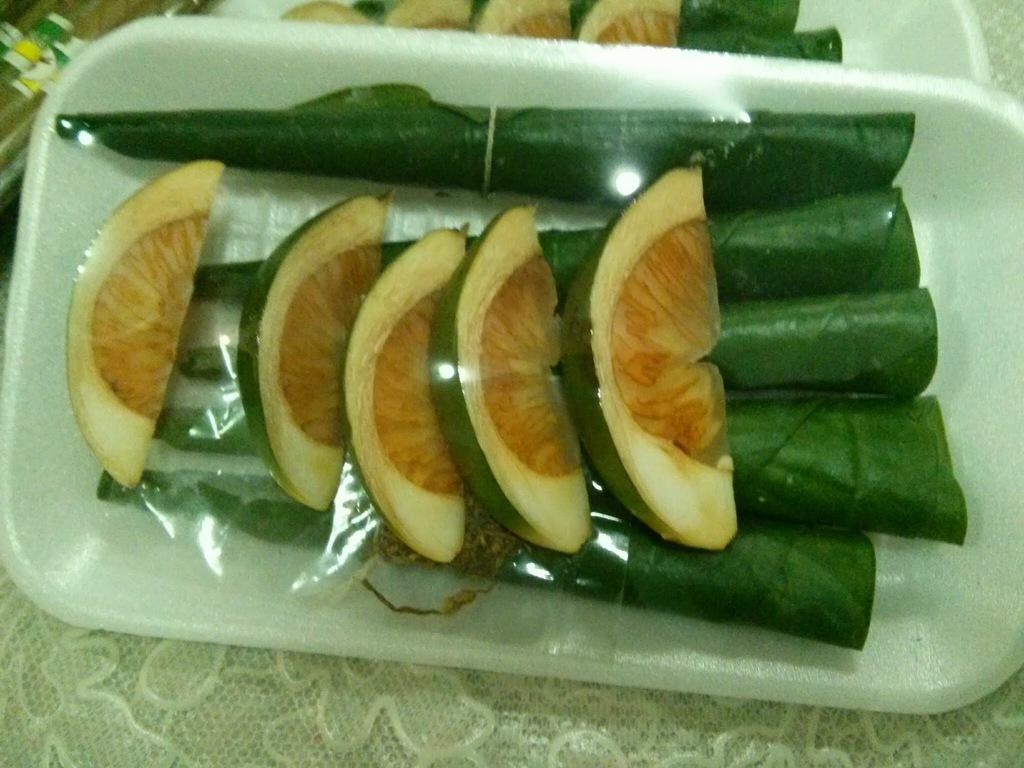What is on the plate in the image? There are fruit slices on rolled leaves in a plate. Where is the plate located? The plate is on a platform. What can be seen in the background of the image? There are objects in the background of the image. What type of error can be seen in the image? There is no error present in the image. What jar is visible in the image? There is no jar present in the image. 